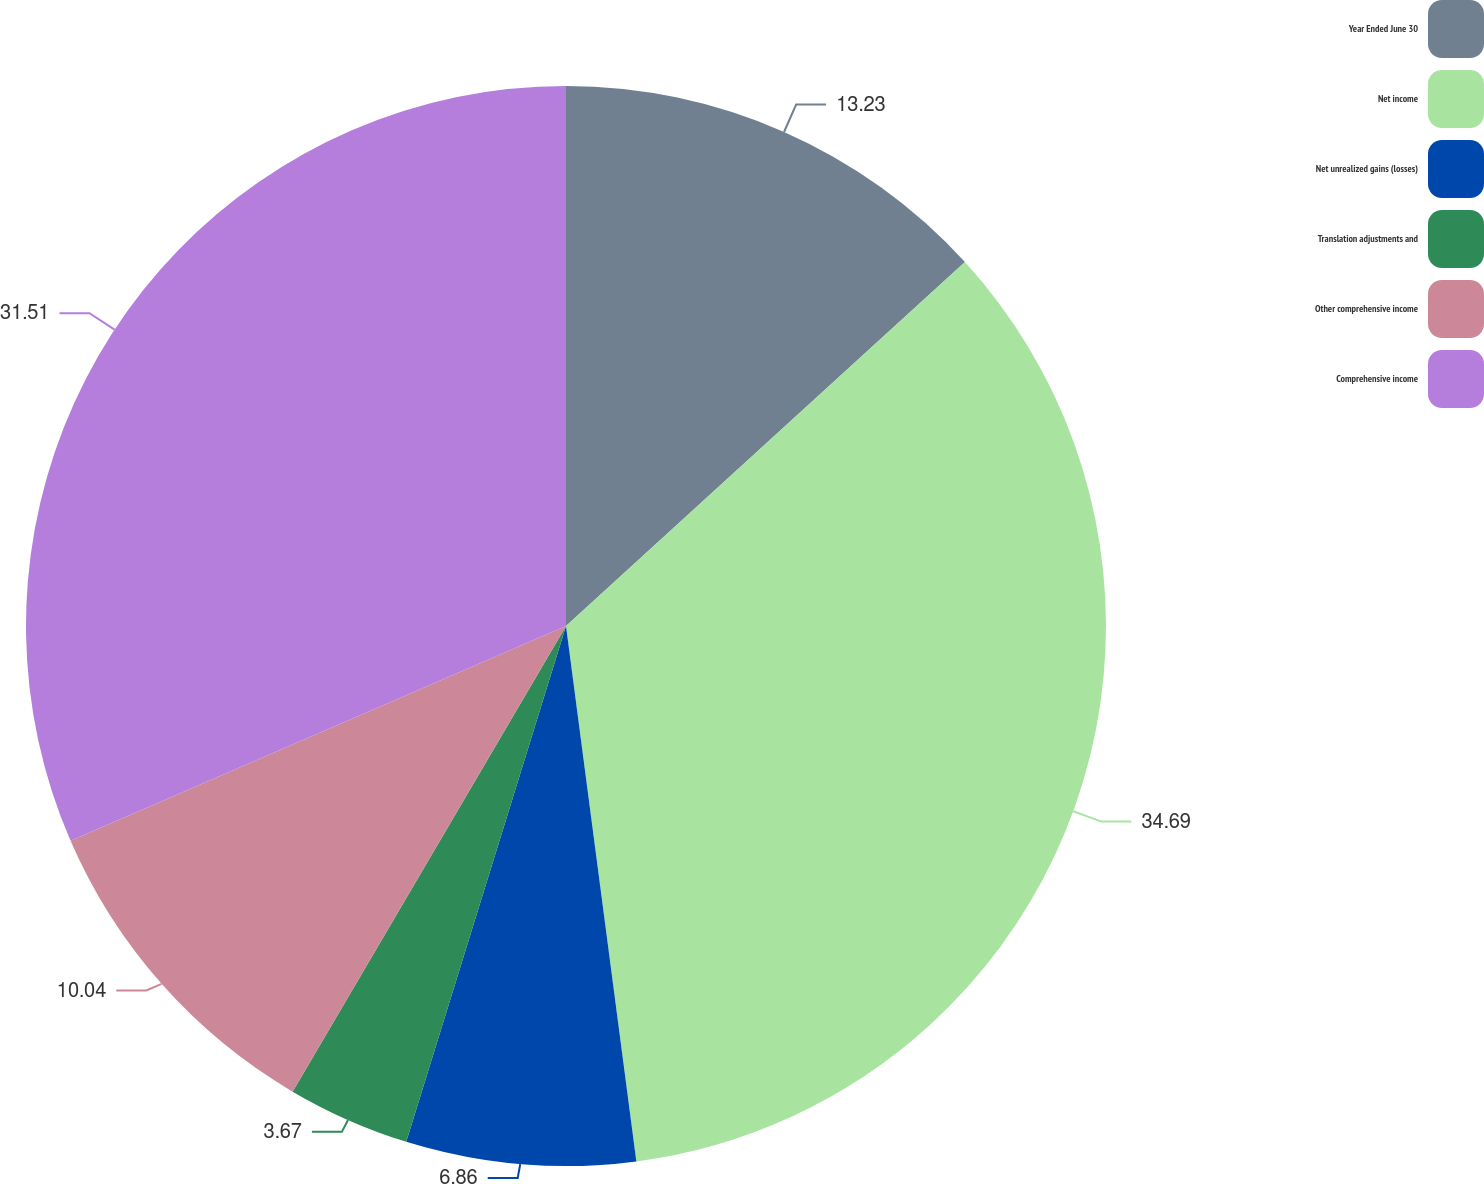Convert chart to OTSL. <chart><loc_0><loc_0><loc_500><loc_500><pie_chart><fcel>Year Ended June 30<fcel>Net income<fcel>Net unrealized gains (losses)<fcel>Translation adjustments and<fcel>Other comprehensive income<fcel>Comprehensive income<nl><fcel>13.23%<fcel>34.69%<fcel>6.86%<fcel>3.67%<fcel>10.04%<fcel>31.51%<nl></chart> 